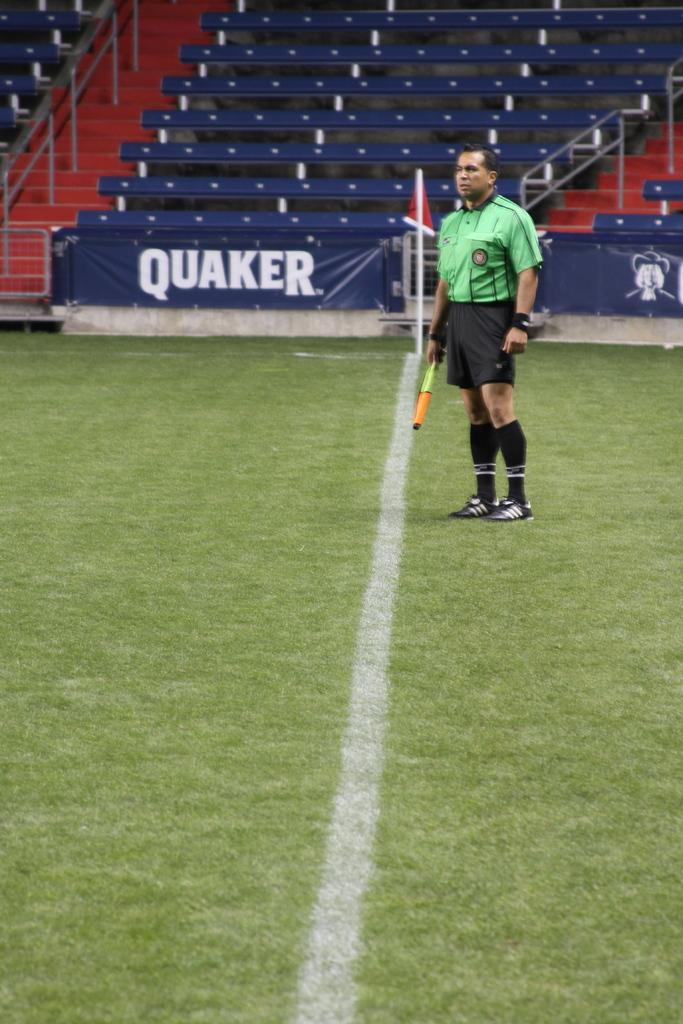What is the person in the image doing? The person is standing in the image. What is the person holding in the image? The person is holding an object. What can be seen in the background of the image? There are banners, benches, a staircase, iron rods, and a flag with a pole in the background of the image. Is the person folding a harbor in the image? There is no harbor present in the image, and the person is not folding anything. Is it raining in the image? There is no indication of rain in the image. 